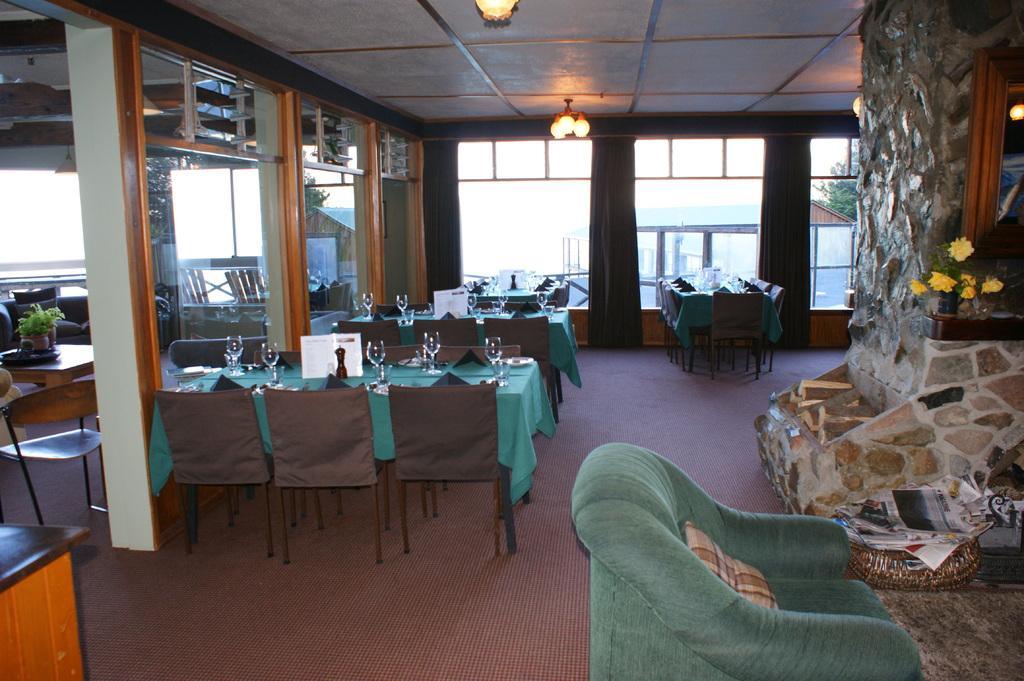Please provide a concise description of this image. in the picture there was a restaurant with the tables,chairs,bottles and glasses over the table,there was also a little plants,here we can also see lights over the roof. 